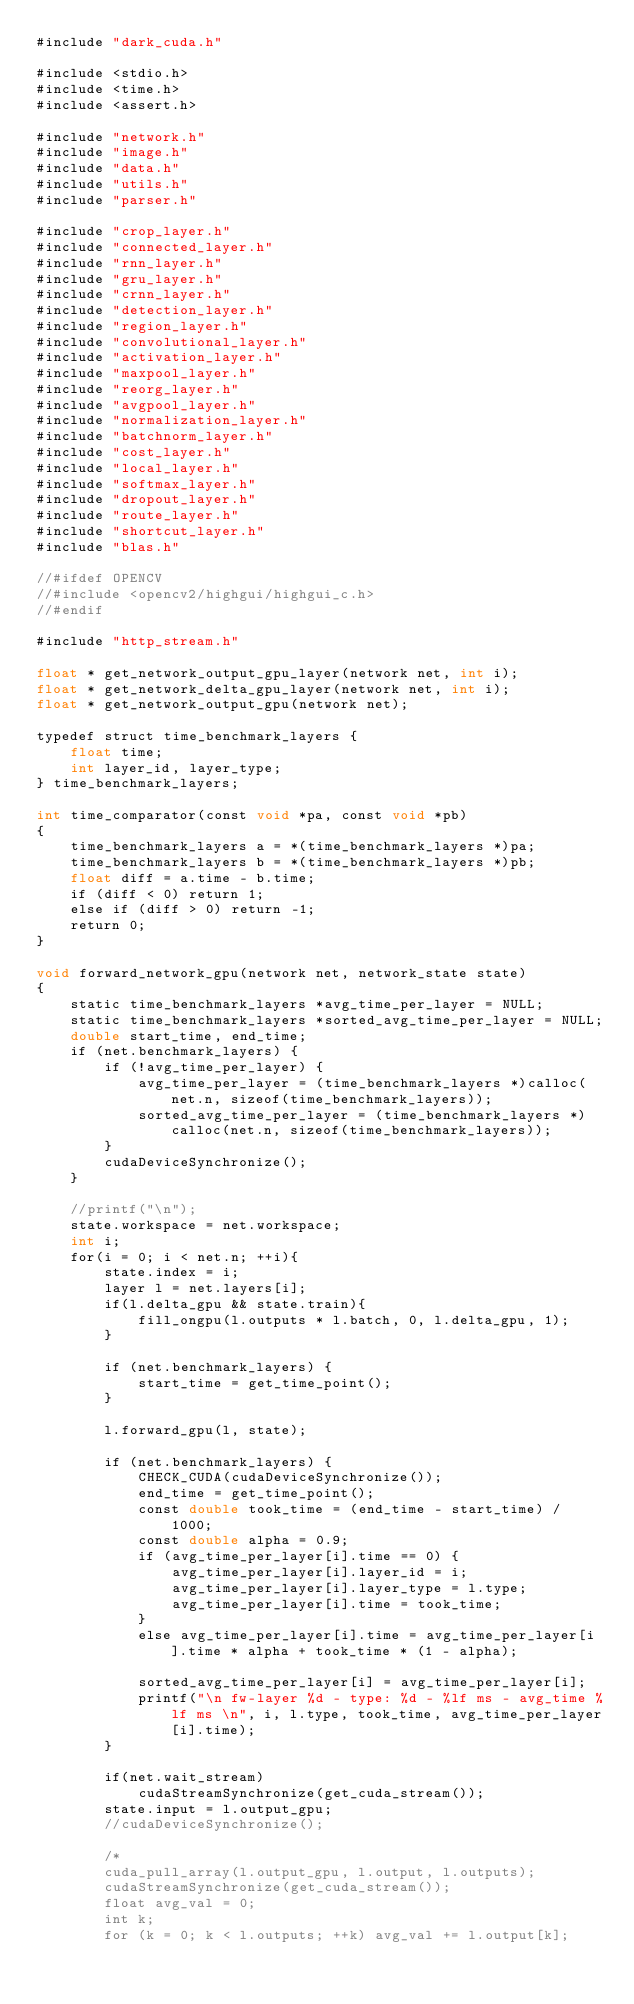Convert code to text. <code><loc_0><loc_0><loc_500><loc_500><_Cuda_>#include "dark_cuda.h"

#include <stdio.h>
#include <time.h>
#include <assert.h>

#include "network.h"
#include "image.h"
#include "data.h"
#include "utils.h"
#include "parser.h"

#include "crop_layer.h"
#include "connected_layer.h"
#include "rnn_layer.h"
#include "gru_layer.h"
#include "crnn_layer.h"
#include "detection_layer.h"
#include "region_layer.h"
#include "convolutional_layer.h"
#include "activation_layer.h"
#include "maxpool_layer.h"
#include "reorg_layer.h"
#include "avgpool_layer.h"
#include "normalization_layer.h"
#include "batchnorm_layer.h"
#include "cost_layer.h"
#include "local_layer.h"
#include "softmax_layer.h"
#include "dropout_layer.h"
#include "route_layer.h"
#include "shortcut_layer.h"
#include "blas.h"

//#ifdef OPENCV
//#include <opencv2/highgui/highgui_c.h>
//#endif

#include "http_stream.h"

float * get_network_output_gpu_layer(network net, int i);
float * get_network_delta_gpu_layer(network net, int i);
float * get_network_output_gpu(network net);

typedef struct time_benchmark_layers {
    float time;
    int layer_id, layer_type;
} time_benchmark_layers;

int time_comparator(const void *pa, const void *pb)
{
    time_benchmark_layers a = *(time_benchmark_layers *)pa;
    time_benchmark_layers b = *(time_benchmark_layers *)pb;
    float diff = a.time - b.time;
    if (diff < 0) return 1;
    else if (diff > 0) return -1;
    return 0;
}

void forward_network_gpu(network net, network_state state)
{
    static time_benchmark_layers *avg_time_per_layer = NULL;
    static time_benchmark_layers *sorted_avg_time_per_layer = NULL;
    double start_time, end_time;
    if (net.benchmark_layers) {
        if (!avg_time_per_layer) {
            avg_time_per_layer = (time_benchmark_layers *)calloc(net.n, sizeof(time_benchmark_layers));
            sorted_avg_time_per_layer = (time_benchmark_layers *)calloc(net.n, sizeof(time_benchmark_layers));
        }
        cudaDeviceSynchronize();
    }

    //printf("\n");
    state.workspace = net.workspace;
    int i;
    for(i = 0; i < net.n; ++i){
        state.index = i;
        layer l = net.layers[i];
        if(l.delta_gpu && state.train){
            fill_ongpu(l.outputs * l.batch, 0, l.delta_gpu, 1);
        }

        if (net.benchmark_layers) {
            start_time = get_time_point();
        }

        l.forward_gpu(l, state);

        if (net.benchmark_layers) {
            CHECK_CUDA(cudaDeviceSynchronize());
            end_time = get_time_point();
            const double took_time = (end_time - start_time) / 1000;
            const double alpha = 0.9;
            if (avg_time_per_layer[i].time == 0) {
                avg_time_per_layer[i].layer_id = i;
                avg_time_per_layer[i].layer_type = l.type;
                avg_time_per_layer[i].time = took_time;
            }
            else avg_time_per_layer[i].time = avg_time_per_layer[i].time * alpha + took_time * (1 - alpha);

            sorted_avg_time_per_layer[i] = avg_time_per_layer[i];
            printf("\n fw-layer %d - type: %d - %lf ms - avg_time %lf ms \n", i, l.type, took_time, avg_time_per_layer[i].time);
        }

        if(net.wait_stream)
            cudaStreamSynchronize(get_cuda_stream());
        state.input = l.output_gpu;
        //cudaDeviceSynchronize();

        /*
        cuda_pull_array(l.output_gpu, l.output, l.outputs);
        cudaStreamSynchronize(get_cuda_stream());
        float avg_val = 0;
        int k;
        for (k = 0; k < l.outputs; ++k) avg_val += l.output[k];</code> 